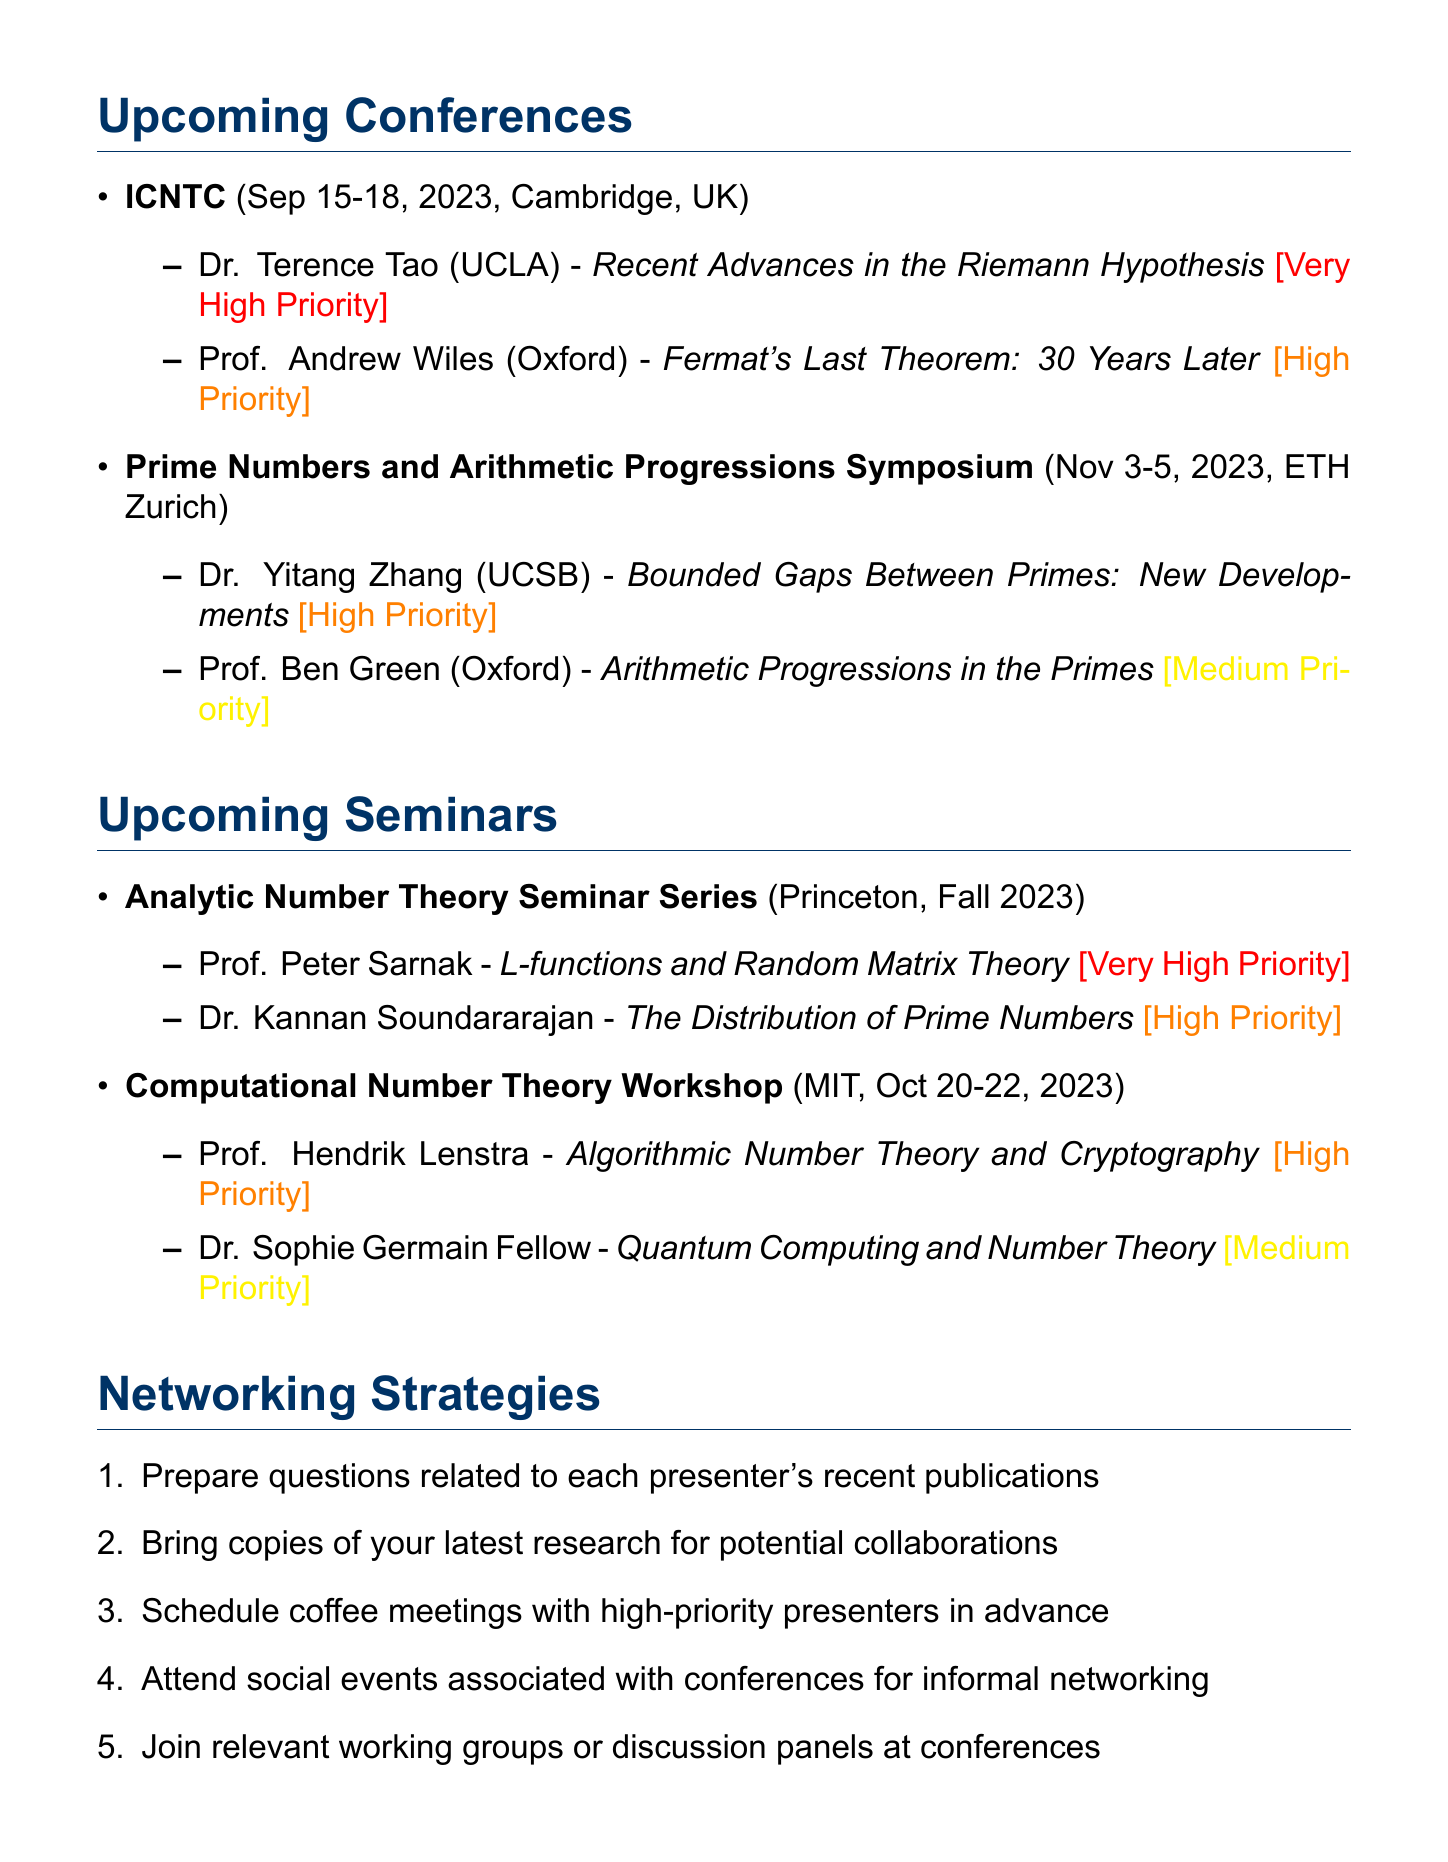What are the dates of the ICNTC? The dates for the International Conference on Number Theory and Cryptography (ICNTC) are listed as September 15-18, 2023.
Answer: September 15-18, 2023 Who is presenting on the topic of "L-functions and Random Matrix Theory"? The document specifies that Prof. Peter Sarnak will present on this topic.
Answer: Prof. Peter Sarnak What is the location of the Prime Numbers and Arithmetic Progressions Symposium? The document states that the location is ETH Zurich, Switzerland.
Answer: ETH Zurich, Switzerland Which presenter has a very high networking priority at Princeton University seminars? The document indicates that Prof. Peter Sarnak has a very high networking priority for his seminar.
Answer: Prof. Peter Sarnak What is the main topic of Dr. Yitang Zhang's presentation? The document lists the topic as "Bounded Gaps Between Primes: New Developments."
Answer: Bounded Gaps Between Primes: New Developments Which presenter’s work aligns with research on Dirichlet L-functions? The document specifies that Prof. Peter Sarnak's expertise aligns with this research focus.
Answer: Prof. Peter Sarnak How many seminars are listed in the document? The document counts two seminars under upcoming seminars.
Answer: 2 What is one suggested networking strategy mentioned? The document lists several strategies, one of which is to "bring copies of your latest research for potential collaborations."
Answer: Bring copies of your latest research for potential collaborations Who is the presenter for the Computational Number Theory Workshop? The document provides both Prof. Hendrik Lenstra and Dr. Sophie Germain Fellow as speakers in this workshop.
Answer: Prof. Hendrik Lenstra, Dr. Sophie Germain Fellow 